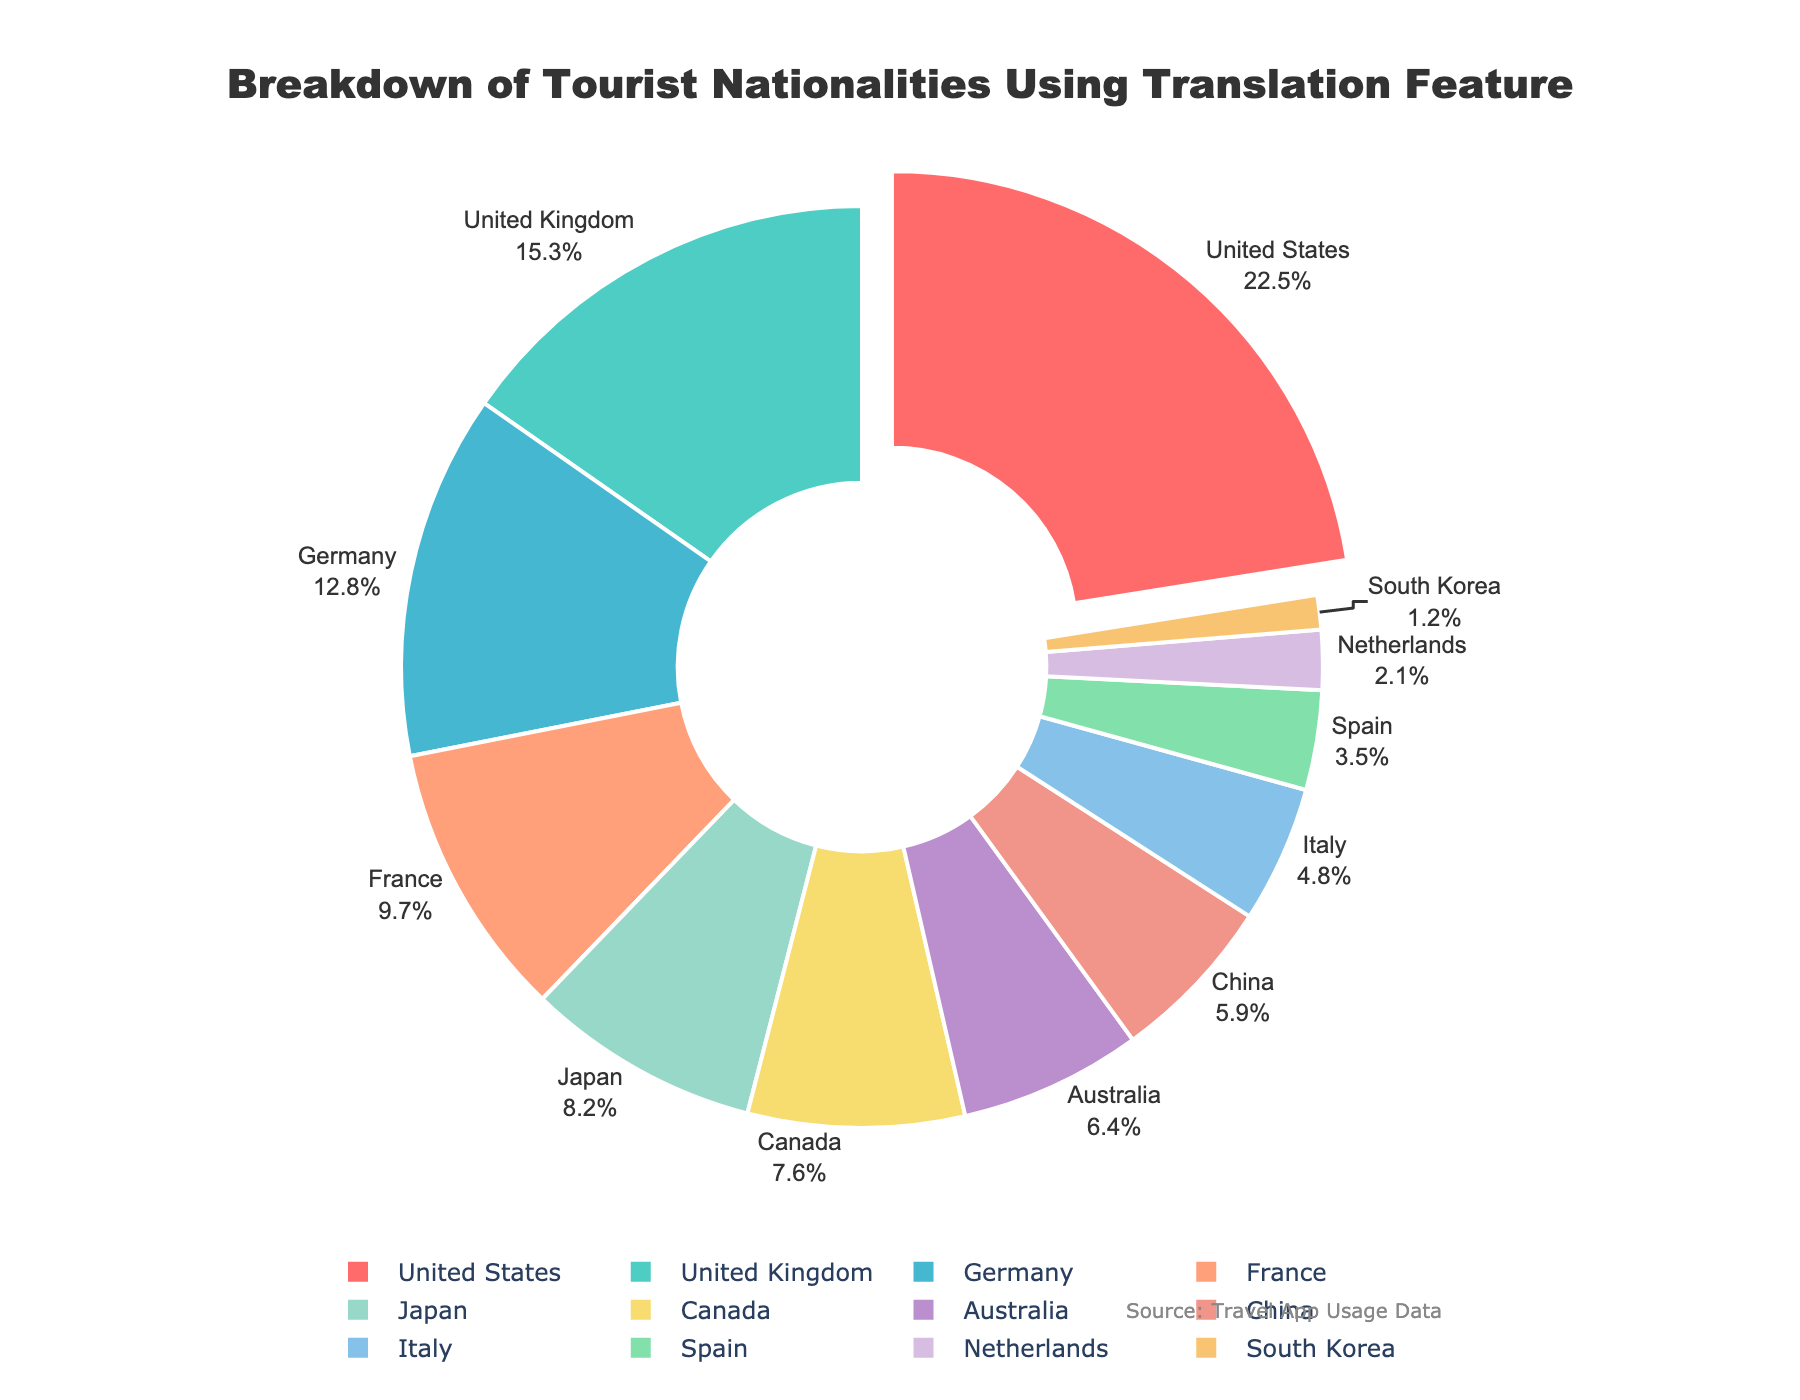Which nationality has the highest percentage of tourists using the translation feature? The nationality with the highest percentage is visually distinguished by being pulled out from the pie chart, which is also the largest segment.
Answer: United States Which two nationalities have a combined percentage greater than 20%? By visually checking, the United Kingdom (15.3%) plus Germany (12.8%) exceeds 20%, as their sum is 28.1%.
Answer: United Kingdom and Germany What is the difference in percentage points between tourists from the United States and Japan? Subtract the percentage of Japan (8.2%) from the United States (22.5%): 22.5% - 8.2% = 14.3 percentage points.
Answer: 14.3 percentage points Which nationality is represented by the light blue segment in the pie chart? The segment color coded in light blue corresponds to the third label in the data set, which is Germany.
Answer: Germany Compare the percentage of tourists from France and Canada. Which has a higher percentage? From the chart, France has 9.7% and Canada has 7.6%. France's percentage is higher than Canada's.
Answer: France Name three nationalities whose combined percentages are less than 10%. Adding the percentages of South Korea (1.2%), Netherlands (2.1%), and Spain (3.5%) results in 1.2% + 2.1% + 3.5% = 6.8%, which is less than 10%.
Answer: South Korea, Netherlands, and Spain Which nationality constitutes less than 5% of the tourists using the translation feature? Looking at the chart, nationalities with less than 5% include Italy (4.8%), Spain (3.5%), Netherlands (2.1%), and South Korea (1.2%).
Answer: Italy, Spain, Netherlands, and South Korea What are the percentages for China and Italy combined? Adding the percentages for China (5.9%) and Italy (4.8%) results in 5.9% + 4.8% = 10.7%.
Answer: 10.7% List the nationalities whose segments are in warm colors (red, orange, yellow). Visual observation of the pie chart indicates the warm-colored sections are for the United States (red), France (orange), and Germany (yellow).
Answer: United States, France, and Germany What is the visual indicator used to highlight the segment with the highest percentage? The segment with the highest percentage is visually distinguished by being pulled out from the pie chart relative to the others.
Answer: Pulled out segment 